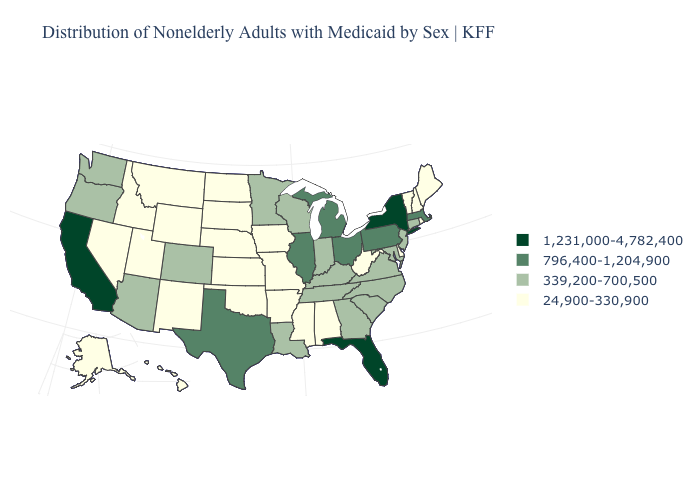Name the states that have a value in the range 24,900-330,900?
Short answer required. Alabama, Alaska, Arkansas, Delaware, Hawaii, Idaho, Iowa, Kansas, Maine, Mississippi, Missouri, Montana, Nebraska, Nevada, New Hampshire, New Mexico, North Dakota, Oklahoma, Rhode Island, South Dakota, Utah, Vermont, West Virginia, Wyoming. What is the value of Nevada?
Short answer required. 24,900-330,900. Name the states that have a value in the range 1,231,000-4,782,400?
Write a very short answer. California, Florida, New York. Does Florida have the highest value in the USA?
Write a very short answer. Yes. What is the lowest value in the USA?
Give a very brief answer. 24,900-330,900. Does Connecticut have a higher value than Hawaii?
Concise answer only. Yes. What is the value of Rhode Island?
Keep it brief. 24,900-330,900. Which states have the lowest value in the South?
Quick response, please. Alabama, Arkansas, Delaware, Mississippi, Oklahoma, West Virginia. What is the lowest value in the USA?
Give a very brief answer. 24,900-330,900. What is the value of Florida?
Concise answer only. 1,231,000-4,782,400. Does the first symbol in the legend represent the smallest category?
Short answer required. No. Among the states that border Maine , which have the lowest value?
Give a very brief answer. New Hampshire. Does Ohio have a lower value than New Mexico?
Be succinct. No. Name the states that have a value in the range 796,400-1,204,900?
Keep it brief. Illinois, Massachusetts, Michigan, Ohio, Pennsylvania, Texas. Does Alabama have the lowest value in the South?
Concise answer only. Yes. 